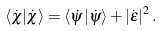<formula> <loc_0><loc_0><loc_500><loc_500>\langle \dot { \chi } | \dot { \chi } \rangle = \langle \dot { \psi } | \dot { \psi } \rangle + | \dot { \epsilon } | ^ { 2 } \, .</formula> 